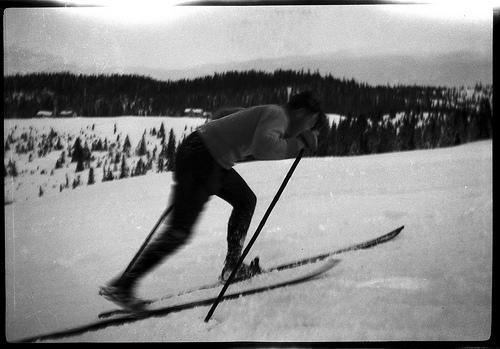How many people are in the picture?
Give a very brief answer. 1. 